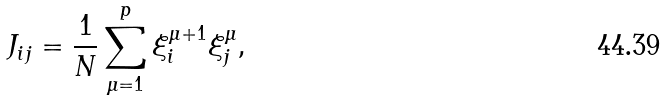Convert formula to latex. <formula><loc_0><loc_0><loc_500><loc_500>J _ { i j } = \frac { 1 } { N } \sum _ { \mu = 1 } ^ { p } \xi ^ { \mu + 1 } _ { i } \xi ^ { \mu } _ { j } ,</formula> 